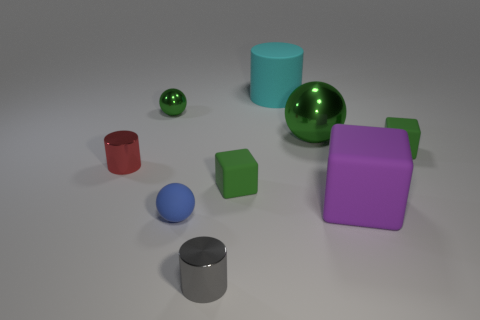Subtract all small metal cylinders. How many cylinders are left? 1 Subtract all red blocks. How many green balls are left? 2 Subtract all blue balls. How many balls are left? 2 Subtract 1 spheres. How many spheres are left? 2 Subtract 1 cyan cylinders. How many objects are left? 8 Subtract all balls. How many objects are left? 6 Subtract all brown cylinders. Subtract all cyan balls. How many cylinders are left? 3 Subtract all tiny green matte cylinders. Subtract all big metallic spheres. How many objects are left? 8 Add 1 large metal balls. How many large metal balls are left? 2 Add 1 big green metallic balls. How many big green metallic balls exist? 2 